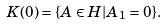Convert formula to latex. <formula><loc_0><loc_0><loc_500><loc_500>K ( 0 ) = \{ A \in H | A _ { 1 } = 0 \} .</formula> 